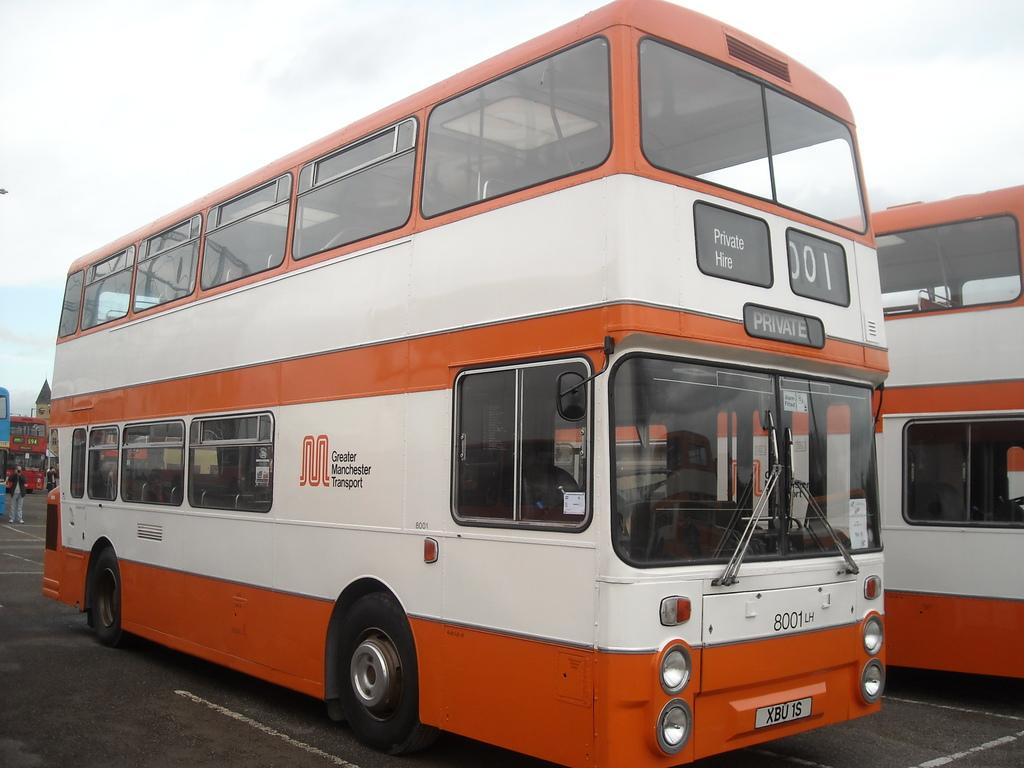What type of vehicles can be seen on the road in the image? There are Double Decker buses on the road in the image. Can you describe the person in the image? There is a person in the image, but their appearance or actions are not specified. What type of building is visible in the image? There is a house in the image. What can be seen in the background of the image? The sky is visible in the background of the image. What type of soup is the person eating in the image? There is no soup present in the image; the person's actions are not specified. How many men are visible in the image? There is no mention of men in the image; only a person is mentioned. 